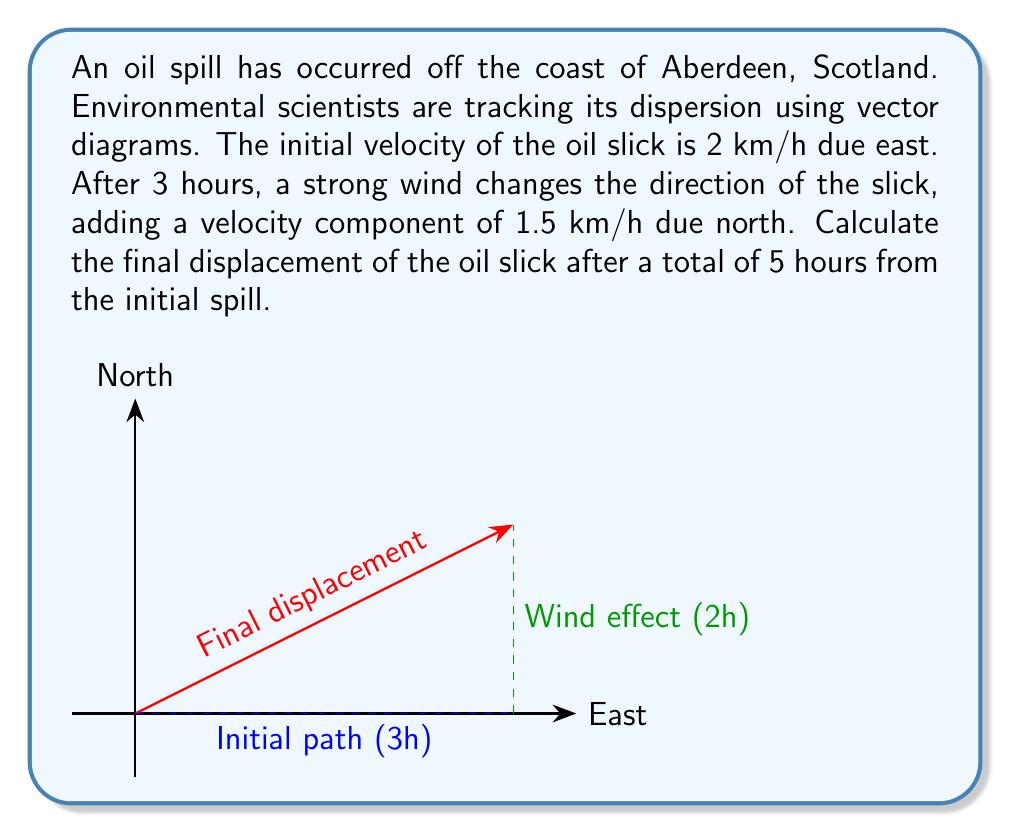Can you answer this question? Let's break this down step-by-step:

1) For the first 3 hours:
   - Velocity = 2 km/h due east
   - Distance traveled = 2 km/h * 3 h = 6 km east
   
2) For the next 2 hours:
   - We have two velocity components:
     a) 2 km/h east (original)
     b) 1.5 km/h north (added by wind)
   - We need to find the resultant velocity using vector addition:
     $$ \vec{v}_{\text{resultant}} = \vec{v}_{\text{east}} + \vec{v}_{\text{north}} $$
   
3) Calculate displacement for the last 2 hours:
   - East component: 2 km/h * 2 h = 4 km
   - North component: 1.5 km/h * 2 h = 3 km

4) Total displacement:
   - East: 6 km (first 3 hours) + 4 km (last 2 hours) = 10 km
   - North: 0 km (first 3 hours) + 3 km (last 2 hours) = 3 km

5) The final displacement is a vector:
   $$ \vec{d} = 10\hat{i} + 3\hat{j} $$
   where $\hat{i}$ is the unit vector east and $\hat{j}$ is the unit vector north.

6) The magnitude of this displacement vector is:
   $$ |\vec{d}| = \sqrt{10^2 + 3^2} = \sqrt{109} \approx 10.44 \text{ km} $$

7) The direction can be found using the arctangent function:
   $$ \theta = \tan^{-1}\left(\frac{3}{10}\right) \approx 16.7° $$
   This angle is measured counterclockwise from the positive x-axis (east).
Answer: $10.44 \text{ km at } 16.7°$ north of east 